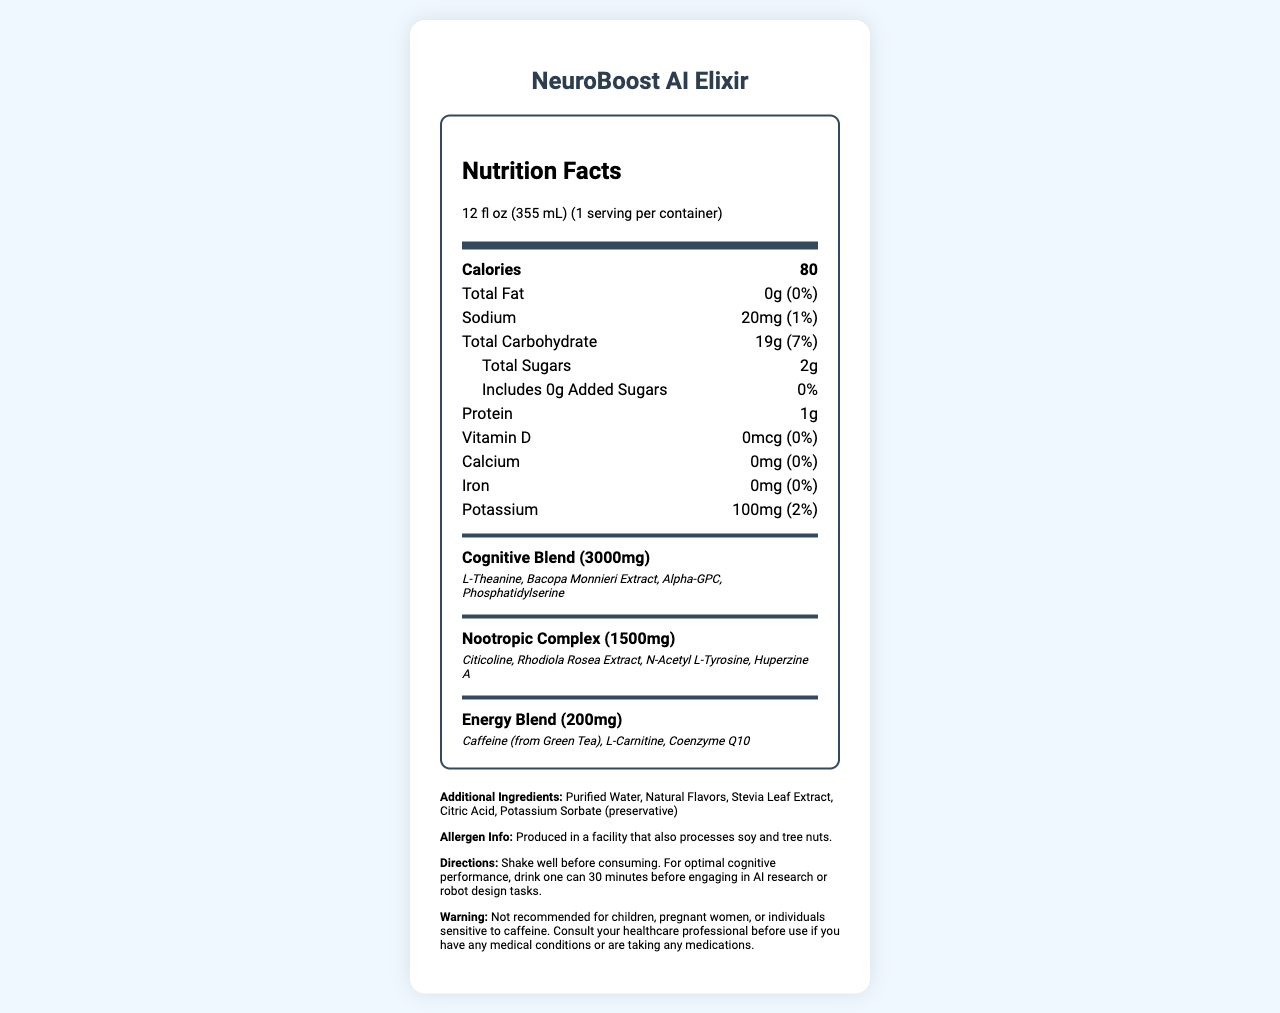what is the serving size of NeuroBoost AI Elixir? The serving size is clearly listed on the label under the "serving size" section.
Answer: 12 fl oz (355 mL) how many calories are there in one serving of NeuroBoost AI Elixir? The calorie count is prominently displayed in the "Calories" section.
Answer: 80 what is the amount of total sugars in one serving? The amount of total sugars is listed under the "Total Sugars" section.
Answer: 2g does the product contain any added sugars? The label states that the amount of added sugars is 0g with a daily value of 0%.
Answer: No how much protein does the beverage contain? The protein content is listed on the label as 1g.
Answer: 1g what is the daily value percentage of sodium in this beverage? The daily value of sodium is indicated as 1% on the label.
Answer: 1% which of the following is not an ingredient in the Cognitive Blend? A. L-Theanine B. Citicoline C. Bacopa Monnieri Extract D. Alpha-GPC The ingredients in the Cognitive Blend are listed as L-Theanine, Bacopa Monnieri Extract, Alpha-GPC, and Phosphatidylserine. Citicoline is part of the Nootropic Complex.
Answer: B how much potassium is present in one serving? The potassium amount is listed on the label as 100mg.
Answer: 100mg what allergen warning is provided for this product? The allergen information on the label states that the product is produced in a facility that also processes soy and tree nuts.
Answer: Produced in a facility that also processes soy and tree nuts. what are the directions for consuming this beverage? The directions for use are clearly outlined on the label.
Answer: Shake well before consuming. For optimal cognitive performance, drink one can 30 minutes before engaging in AI research or robot design tasks. which of the following ingredients is part of the Energy Blend? A. Rhodiola Rosea Extract B. Coenzyme Q10 C. N-Acetyl L-Tyrosine D. Bacopa Monnieri Extract The ingredients in the Energy Blend include Caffeine (from Green Tea), L-Carnitine, and Coenzyme Q10. Rhodiola Rosea Extract and N-Acetyl L-Tyrosine are part of the Nootropic Complex, and Bacopa Monnieri Extract is part of the Cognitive Blend.
Answer: B is this beverage suitable for children? The warning section clearly states that it is not recommended for children, pregnant women, or individuals sensitive to caffeine.
Answer: No summarize the key nutritional information and ingredients of NeuroBoost AI Elixir. This description encompasses the primary nutritional values, specialized blends, additional ingredients, and usage instructions.
Answer: NeuroBoost AI Elixir is a brain-boosting beverage formulated for AI researchers. Each 12 fl oz serving contains 80 calories, 0g total fat, 20mg sodium, 19g total carbohydrates, 2g total sugars, 1g protein, 0% daily values of vitamin D, calcium, and iron, and 100mg potassium. The beverage features three specialized blends: a cognitive blend with 3000mg including L-Theanine and Bacopa Monnieri Extract; a nootropic complex with 1500mg including Citicoline and Rhodiola Rosea Extract; and an energy blend with 200mg including Caffeine and Coenzyme Q10. Additional ingredients include purified water, natural flavors, and stevia leaf extract. It also includes instructions and warnings about consumption. how many milligrams of iron does this beverage have? The iron content is clearly indicated as 0mg on the label.
Answer: 0mg 